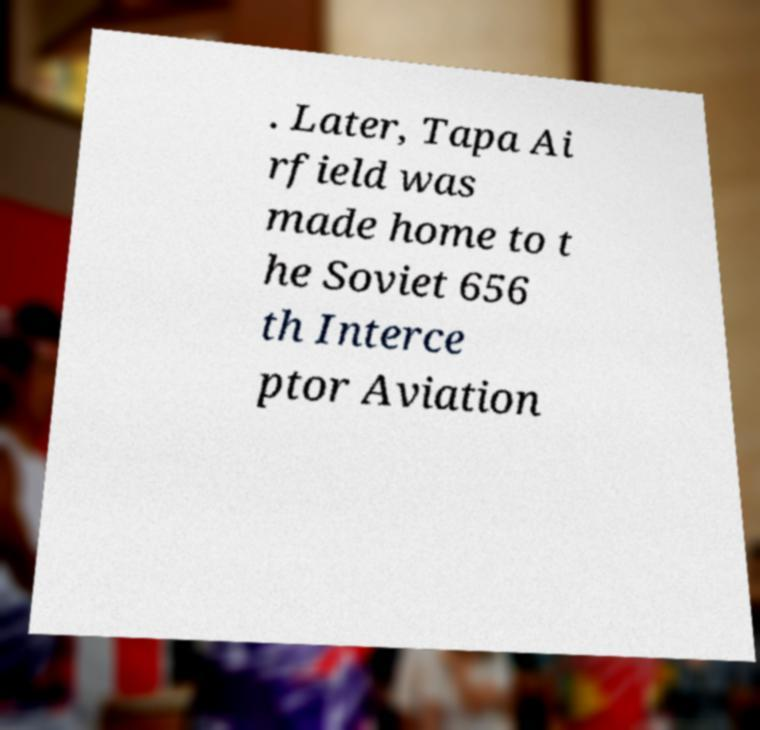Can you accurately transcribe the text from the provided image for me? . Later, Tapa Ai rfield was made home to t he Soviet 656 th Interce ptor Aviation 